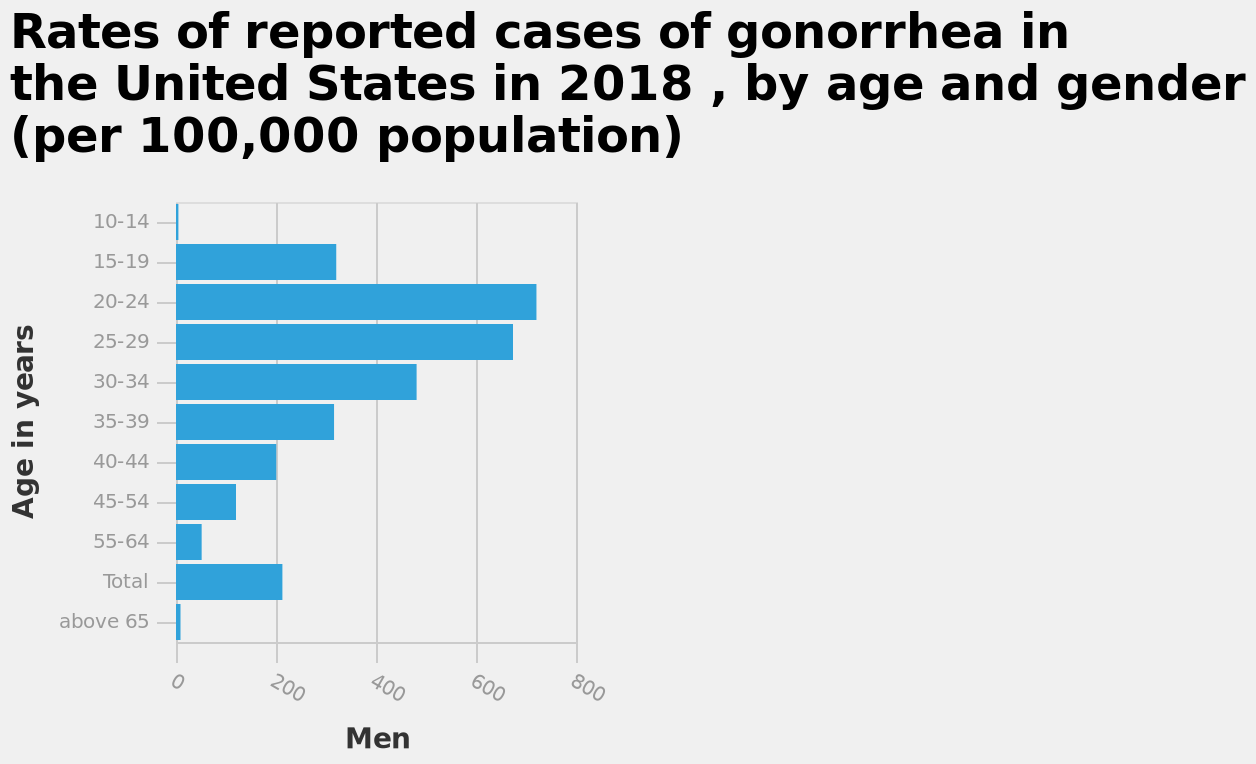<image>
What age group has the highest rates of the disease?  Men aged 20-24 have the highest rates of the disease. What is the title of the bar diagram? The title of the bar diagram is "Rates of reported cases of gonorrhea in the United States in 2018, by age and gender (per 100,000 population)". 